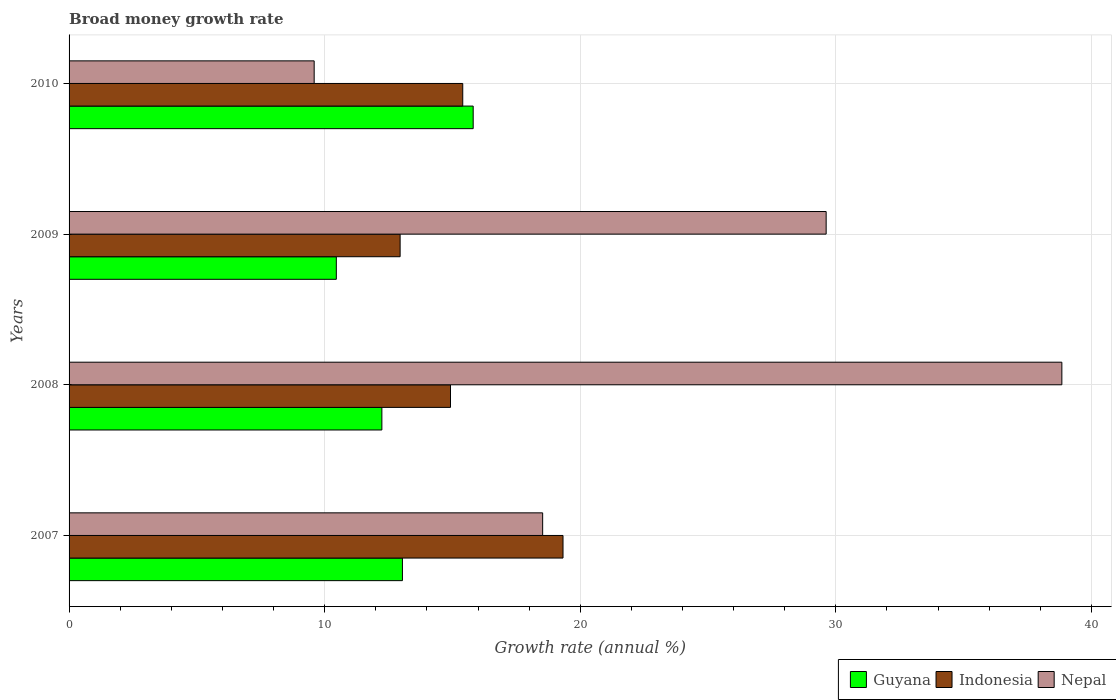Are the number of bars on each tick of the Y-axis equal?
Offer a very short reply. Yes. How many bars are there on the 3rd tick from the top?
Give a very brief answer. 3. How many bars are there on the 2nd tick from the bottom?
Your answer should be very brief. 3. What is the label of the 2nd group of bars from the top?
Provide a short and direct response. 2009. What is the growth rate in Indonesia in 2010?
Provide a succinct answer. 15.4. Across all years, what is the maximum growth rate in Guyana?
Provide a succinct answer. 15.81. Across all years, what is the minimum growth rate in Guyana?
Give a very brief answer. 10.46. In which year was the growth rate in Guyana minimum?
Provide a short and direct response. 2009. What is the total growth rate in Nepal in the graph?
Keep it short and to the point. 96.58. What is the difference between the growth rate in Indonesia in 2009 and that in 2010?
Your response must be concise. -2.45. What is the difference between the growth rate in Indonesia in 2009 and the growth rate in Guyana in 2008?
Your response must be concise. 0.71. What is the average growth rate in Nepal per year?
Provide a short and direct response. 24.14. In the year 2007, what is the difference between the growth rate in Guyana and growth rate in Nepal?
Your answer should be compact. -5.49. What is the ratio of the growth rate in Guyana in 2007 to that in 2008?
Ensure brevity in your answer.  1.07. Is the growth rate in Indonesia in 2007 less than that in 2008?
Give a very brief answer. No. Is the difference between the growth rate in Guyana in 2007 and 2008 greater than the difference between the growth rate in Nepal in 2007 and 2008?
Keep it short and to the point. Yes. What is the difference between the highest and the second highest growth rate in Nepal?
Keep it short and to the point. 9.22. What is the difference between the highest and the lowest growth rate in Indonesia?
Offer a very short reply. 6.37. In how many years, is the growth rate in Guyana greater than the average growth rate in Guyana taken over all years?
Offer a terse response. 2. What does the 3rd bar from the top in 2007 represents?
Ensure brevity in your answer.  Guyana. Is it the case that in every year, the sum of the growth rate in Guyana and growth rate in Indonesia is greater than the growth rate in Nepal?
Offer a very short reply. No. How many bars are there?
Make the answer very short. 12. What is the difference between two consecutive major ticks on the X-axis?
Your answer should be compact. 10. Does the graph contain any zero values?
Your answer should be compact. No. Where does the legend appear in the graph?
Your answer should be very brief. Bottom right. How many legend labels are there?
Your response must be concise. 3. What is the title of the graph?
Offer a terse response. Broad money growth rate. What is the label or title of the X-axis?
Keep it short and to the point. Growth rate (annual %). What is the label or title of the Y-axis?
Your answer should be very brief. Years. What is the Growth rate (annual %) of Guyana in 2007?
Offer a terse response. 13.04. What is the Growth rate (annual %) in Indonesia in 2007?
Offer a terse response. 19.33. What is the Growth rate (annual %) of Nepal in 2007?
Your answer should be compact. 18.53. What is the Growth rate (annual %) in Guyana in 2008?
Offer a very short reply. 12.24. What is the Growth rate (annual %) in Indonesia in 2008?
Provide a short and direct response. 14.92. What is the Growth rate (annual %) in Nepal in 2008?
Provide a succinct answer. 38.84. What is the Growth rate (annual %) in Guyana in 2009?
Provide a short and direct response. 10.46. What is the Growth rate (annual %) in Indonesia in 2009?
Keep it short and to the point. 12.95. What is the Growth rate (annual %) in Nepal in 2009?
Your answer should be compact. 29.62. What is the Growth rate (annual %) in Guyana in 2010?
Give a very brief answer. 15.81. What is the Growth rate (annual %) in Indonesia in 2010?
Your answer should be compact. 15.4. What is the Growth rate (annual %) in Nepal in 2010?
Offer a terse response. 9.59. Across all years, what is the maximum Growth rate (annual %) in Guyana?
Make the answer very short. 15.81. Across all years, what is the maximum Growth rate (annual %) of Indonesia?
Give a very brief answer. 19.33. Across all years, what is the maximum Growth rate (annual %) of Nepal?
Make the answer very short. 38.84. Across all years, what is the minimum Growth rate (annual %) in Guyana?
Your response must be concise. 10.46. Across all years, what is the minimum Growth rate (annual %) of Indonesia?
Ensure brevity in your answer.  12.95. Across all years, what is the minimum Growth rate (annual %) in Nepal?
Keep it short and to the point. 9.59. What is the total Growth rate (annual %) of Guyana in the graph?
Keep it short and to the point. 51.55. What is the total Growth rate (annual %) of Indonesia in the graph?
Make the answer very short. 62.6. What is the total Growth rate (annual %) of Nepal in the graph?
Your answer should be compact. 96.58. What is the difference between the Growth rate (annual %) in Guyana in 2007 and that in 2008?
Your response must be concise. 0.8. What is the difference between the Growth rate (annual %) of Indonesia in 2007 and that in 2008?
Keep it short and to the point. 4.4. What is the difference between the Growth rate (annual %) of Nepal in 2007 and that in 2008?
Offer a terse response. -20.31. What is the difference between the Growth rate (annual %) of Guyana in 2007 and that in 2009?
Ensure brevity in your answer.  2.59. What is the difference between the Growth rate (annual %) of Indonesia in 2007 and that in 2009?
Your response must be concise. 6.37. What is the difference between the Growth rate (annual %) of Nepal in 2007 and that in 2009?
Keep it short and to the point. -11.09. What is the difference between the Growth rate (annual %) in Guyana in 2007 and that in 2010?
Keep it short and to the point. -2.77. What is the difference between the Growth rate (annual %) of Indonesia in 2007 and that in 2010?
Offer a very short reply. 3.92. What is the difference between the Growth rate (annual %) in Nepal in 2007 and that in 2010?
Keep it short and to the point. 8.94. What is the difference between the Growth rate (annual %) in Guyana in 2008 and that in 2009?
Your answer should be very brief. 1.78. What is the difference between the Growth rate (annual %) in Indonesia in 2008 and that in 2009?
Your answer should be very brief. 1.97. What is the difference between the Growth rate (annual %) of Nepal in 2008 and that in 2009?
Make the answer very short. 9.22. What is the difference between the Growth rate (annual %) of Guyana in 2008 and that in 2010?
Provide a succinct answer. -3.57. What is the difference between the Growth rate (annual %) of Indonesia in 2008 and that in 2010?
Make the answer very short. -0.48. What is the difference between the Growth rate (annual %) of Nepal in 2008 and that in 2010?
Your answer should be very brief. 29.25. What is the difference between the Growth rate (annual %) of Guyana in 2009 and that in 2010?
Keep it short and to the point. -5.35. What is the difference between the Growth rate (annual %) of Indonesia in 2009 and that in 2010?
Make the answer very short. -2.45. What is the difference between the Growth rate (annual %) of Nepal in 2009 and that in 2010?
Make the answer very short. 20.03. What is the difference between the Growth rate (annual %) of Guyana in 2007 and the Growth rate (annual %) of Indonesia in 2008?
Keep it short and to the point. -1.88. What is the difference between the Growth rate (annual %) of Guyana in 2007 and the Growth rate (annual %) of Nepal in 2008?
Your response must be concise. -25.8. What is the difference between the Growth rate (annual %) of Indonesia in 2007 and the Growth rate (annual %) of Nepal in 2008?
Offer a terse response. -19.52. What is the difference between the Growth rate (annual %) in Guyana in 2007 and the Growth rate (annual %) in Indonesia in 2009?
Your answer should be compact. 0.09. What is the difference between the Growth rate (annual %) in Guyana in 2007 and the Growth rate (annual %) in Nepal in 2009?
Ensure brevity in your answer.  -16.58. What is the difference between the Growth rate (annual %) of Indonesia in 2007 and the Growth rate (annual %) of Nepal in 2009?
Offer a very short reply. -10.29. What is the difference between the Growth rate (annual %) of Guyana in 2007 and the Growth rate (annual %) of Indonesia in 2010?
Provide a succinct answer. -2.36. What is the difference between the Growth rate (annual %) of Guyana in 2007 and the Growth rate (annual %) of Nepal in 2010?
Give a very brief answer. 3.45. What is the difference between the Growth rate (annual %) of Indonesia in 2007 and the Growth rate (annual %) of Nepal in 2010?
Make the answer very short. 9.74. What is the difference between the Growth rate (annual %) in Guyana in 2008 and the Growth rate (annual %) in Indonesia in 2009?
Your response must be concise. -0.71. What is the difference between the Growth rate (annual %) in Guyana in 2008 and the Growth rate (annual %) in Nepal in 2009?
Make the answer very short. -17.38. What is the difference between the Growth rate (annual %) of Indonesia in 2008 and the Growth rate (annual %) of Nepal in 2009?
Your response must be concise. -14.7. What is the difference between the Growth rate (annual %) in Guyana in 2008 and the Growth rate (annual %) in Indonesia in 2010?
Your answer should be very brief. -3.16. What is the difference between the Growth rate (annual %) of Guyana in 2008 and the Growth rate (annual %) of Nepal in 2010?
Keep it short and to the point. 2.65. What is the difference between the Growth rate (annual %) of Indonesia in 2008 and the Growth rate (annual %) of Nepal in 2010?
Keep it short and to the point. 5.33. What is the difference between the Growth rate (annual %) in Guyana in 2009 and the Growth rate (annual %) in Indonesia in 2010?
Your answer should be very brief. -4.95. What is the difference between the Growth rate (annual %) of Guyana in 2009 and the Growth rate (annual %) of Nepal in 2010?
Offer a terse response. 0.87. What is the difference between the Growth rate (annual %) of Indonesia in 2009 and the Growth rate (annual %) of Nepal in 2010?
Offer a terse response. 3.36. What is the average Growth rate (annual %) in Guyana per year?
Make the answer very short. 12.89. What is the average Growth rate (annual %) of Indonesia per year?
Offer a very short reply. 15.65. What is the average Growth rate (annual %) in Nepal per year?
Ensure brevity in your answer.  24.14. In the year 2007, what is the difference between the Growth rate (annual %) in Guyana and Growth rate (annual %) in Indonesia?
Offer a very short reply. -6.28. In the year 2007, what is the difference between the Growth rate (annual %) in Guyana and Growth rate (annual %) in Nepal?
Your answer should be very brief. -5.49. In the year 2007, what is the difference between the Growth rate (annual %) in Indonesia and Growth rate (annual %) in Nepal?
Provide a short and direct response. 0.8. In the year 2008, what is the difference between the Growth rate (annual %) in Guyana and Growth rate (annual %) in Indonesia?
Your answer should be very brief. -2.68. In the year 2008, what is the difference between the Growth rate (annual %) of Guyana and Growth rate (annual %) of Nepal?
Offer a very short reply. -26.6. In the year 2008, what is the difference between the Growth rate (annual %) in Indonesia and Growth rate (annual %) in Nepal?
Keep it short and to the point. -23.92. In the year 2009, what is the difference between the Growth rate (annual %) in Guyana and Growth rate (annual %) in Indonesia?
Make the answer very short. -2.5. In the year 2009, what is the difference between the Growth rate (annual %) in Guyana and Growth rate (annual %) in Nepal?
Offer a very short reply. -19.16. In the year 2009, what is the difference between the Growth rate (annual %) of Indonesia and Growth rate (annual %) of Nepal?
Provide a succinct answer. -16.67. In the year 2010, what is the difference between the Growth rate (annual %) of Guyana and Growth rate (annual %) of Indonesia?
Your answer should be compact. 0.41. In the year 2010, what is the difference between the Growth rate (annual %) of Guyana and Growth rate (annual %) of Nepal?
Keep it short and to the point. 6.22. In the year 2010, what is the difference between the Growth rate (annual %) of Indonesia and Growth rate (annual %) of Nepal?
Your response must be concise. 5.81. What is the ratio of the Growth rate (annual %) in Guyana in 2007 to that in 2008?
Make the answer very short. 1.07. What is the ratio of the Growth rate (annual %) in Indonesia in 2007 to that in 2008?
Provide a succinct answer. 1.29. What is the ratio of the Growth rate (annual %) in Nepal in 2007 to that in 2008?
Offer a very short reply. 0.48. What is the ratio of the Growth rate (annual %) in Guyana in 2007 to that in 2009?
Your response must be concise. 1.25. What is the ratio of the Growth rate (annual %) in Indonesia in 2007 to that in 2009?
Your answer should be very brief. 1.49. What is the ratio of the Growth rate (annual %) of Nepal in 2007 to that in 2009?
Your answer should be compact. 0.63. What is the ratio of the Growth rate (annual %) in Guyana in 2007 to that in 2010?
Your response must be concise. 0.82. What is the ratio of the Growth rate (annual %) in Indonesia in 2007 to that in 2010?
Give a very brief answer. 1.25. What is the ratio of the Growth rate (annual %) of Nepal in 2007 to that in 2010?
Provide a succinct answer. 1.93. What is the ratio of the Growth rate (annual %) in Guyana in 2008 to that in 2009?
Your answer should be compact. 1.17. What is the ratio of the Growth rate (annual %) in Indonesia in 2008 to that in 2009?
Provide a succinct answer. 1.15. What is the ratio of the Growth rate (annual %) in Nepal in 2008 to that in 2009?
Ensure brevity in your answer.  1.31. What is the ratio of the Growth rate (annual %) of Guyana in 2008 to that in 2010?
Offer a very short reply. 0.77. What is the ratio of the Growth rate (annual %) in Indonesia in 2008 to that in 2010?
Provide a succinct answer. 0.97. What is the ratio of the Growth rate (annual %) of Nepal in 2008 to that in 2010?
Offer a terse response. 4.05. What is the ratio of the Growth rate (annual %) in Guyana in 2009 to that in 2010?
Your answer should be compact. 0.66. What is the ratio of the Growth rate (annual %) of Indonesia in 2009 to that in 2010?
Keep it short and to the point. 0.84. What is the ratio of the Growth rate (annual %) of Nepal in 2009 to that in 2010?
Your answer should be compact. 3.09. What is the difference between the highest and the second highest Growth rate (annual %) of Guyana?
Provide a short and direct response. 2.77. What is the difference between the highest and the second highest Growth rate (annual %) in Indonesia?
Give a very brief answer. 3.92. What is the difference between the highest and the second highest Growth rate (annual %) in Nepal?
Provide a succinct answer. 9.22. What is the difference between the highest and the lowest Growth rate (annual %) in Guyana?
Your response must be concise. 5.35. What is the difference between the highest and the lowest Growth rate (annual %) of Indonesia?
Offer a terse response. 6.37. What is the difference between the highest and the lowest Growth rate (annual %) of Nepal?
Keep it short and to the point. 29.25. 